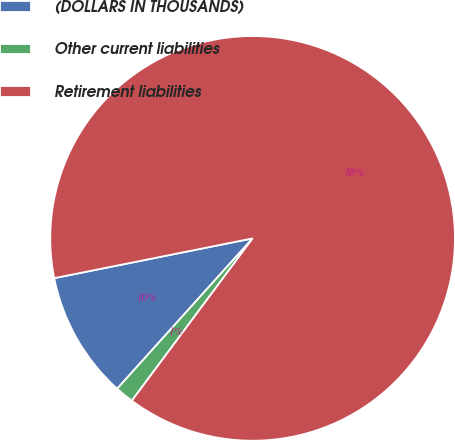Convert chart to OTSL. <chart><loc_0><loc_0><loc_500><loc_500><pie_chart><fcel>(DOLLARS IN THOUSANDS)<fcel>Other current liabilities<fcel>Retirement liabilities<nl><fcel>10.18%<fcel>1.49%<fcel>88.33%<nl></chart> 